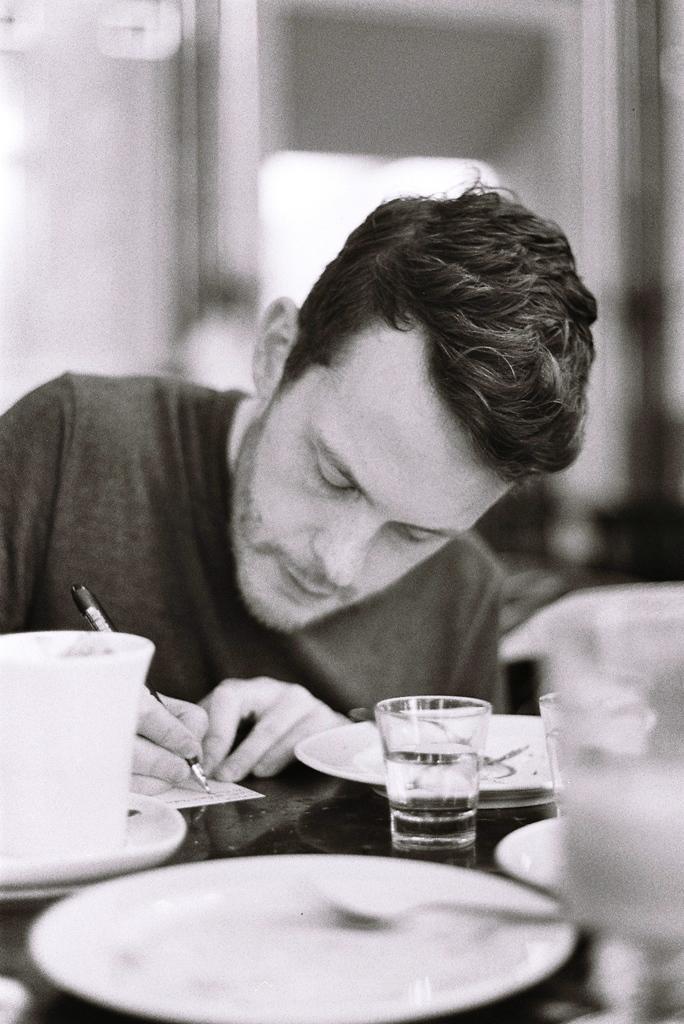In one or two sentences, can you explain what this image depicts? In this image the man is sitting and is taking support of the table and is writing on a paper holding a pen. In front of him there are the plates which are empty, and a glass, and a cup. 